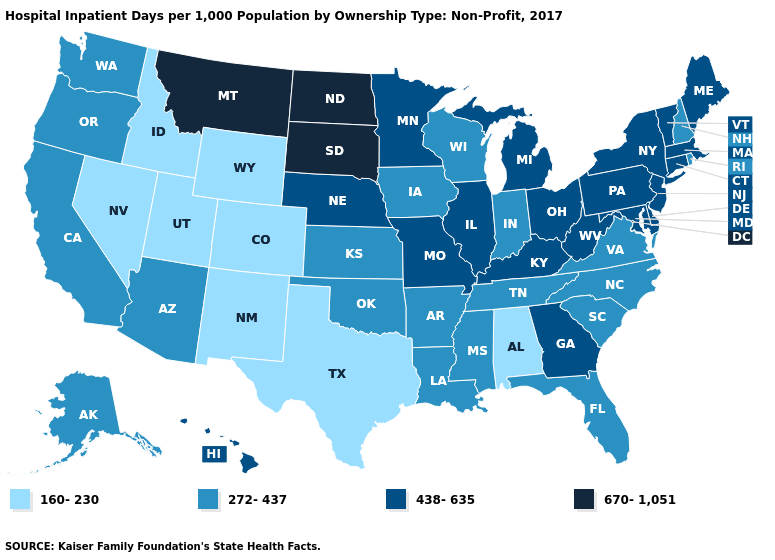Name the states that have a value in the range 670-1,051?
Write a very short answer. Montana, North Dakota, South Dakota. What is the highest value in the Northeast ?
Concise answer only. 438-635. What is the value of South Dakota?
Be succinct. 670-1,051. What is the value of Vermont?
Short answer required. 438-635. What is the value of California?
Quick response, please. 272-437. What is the value of New Hampshire?
Give a very brief answer. 272-437. What is the value of New Mexico?
Write a very short answer. 160-230. What is the highest value in the MidWest ?
Short answer required. 670-1,051. What is the value of Maryland?
Answer briefly. 438-635. Name the states that have a value in the range 670-1,051?
Keep it brief. Montana, North Dakota, South Dakota. Name the states that have a value in the range 438-635?
Quick response, please. Connecticut, Delaware, Georgia, Hawaii, Illinois, Kentucky, Maine, Maryland, Massachusetts, Michigan, Minnesota, Missouri, Nebraska, New Jersey, New York, Ohio, Pennsylvania, Vermont, West Virginia. Name the states that have a value in the range 272-437?
Be succinct. Alaska, Arizona, Arkansas, California, Florida, Indiana, Iowa, Kansas, Louisiana, Mississippi, New Hampshire, North Carolina, Oklahoma, Oregon, Rhode Island, South Carolina, Tennessee, Virginia, Washington, Wisconsin. What is the highest value in the USA?
Write a very short answer. 670-1,051. What is the value of Oregon?
Write a very short answer. 272-437. What is the value of Illinois?
Give a very brief answer. 438-635. 